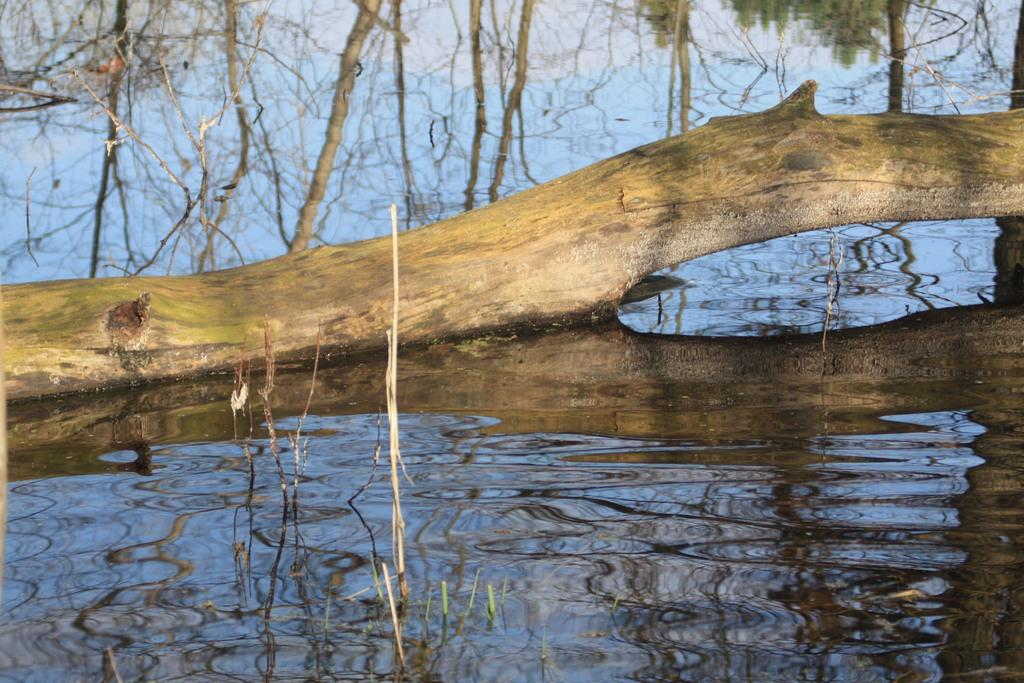What is in the water in the image? There is a wooden branch in the water. What can be seen in the water due to the reflection of objects? There are reflections of trees in the water. What type of pleasure can be seen enjoying the grapes in the image? There is no pleasure or grapes present in the image; it features a wooden branch in the water and reflections of trees. Can you tell me how many horses are visible in the image? There are no horses present in the image. 